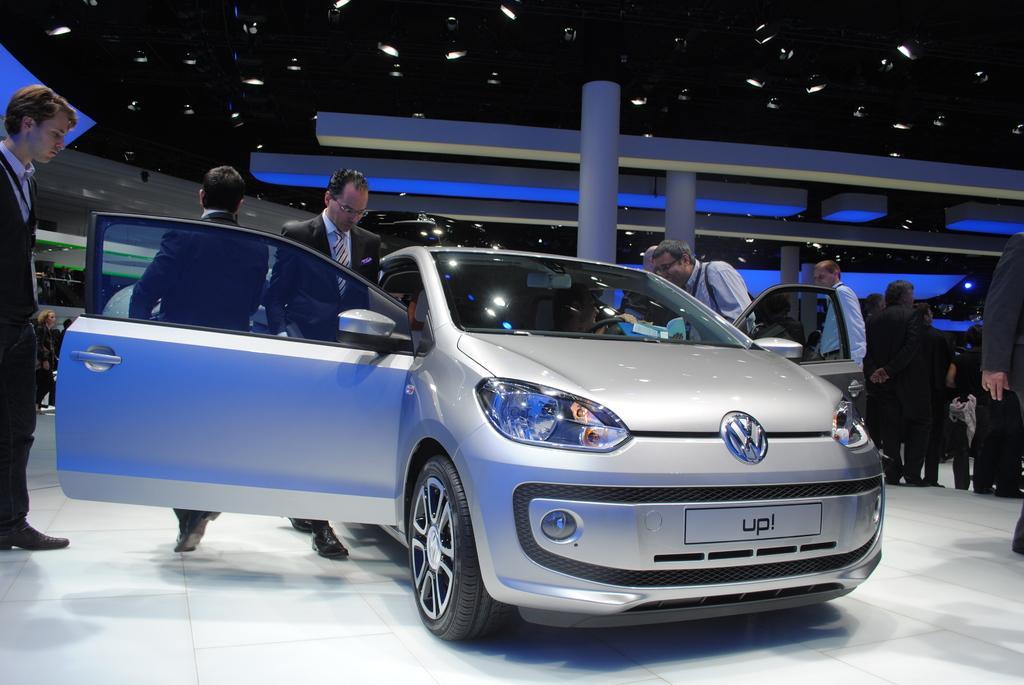How would you summarize this image in a sentence or two? In this image we can see a car. There are many lights in the image. There are many people in the image. There are some reflections on the car. 